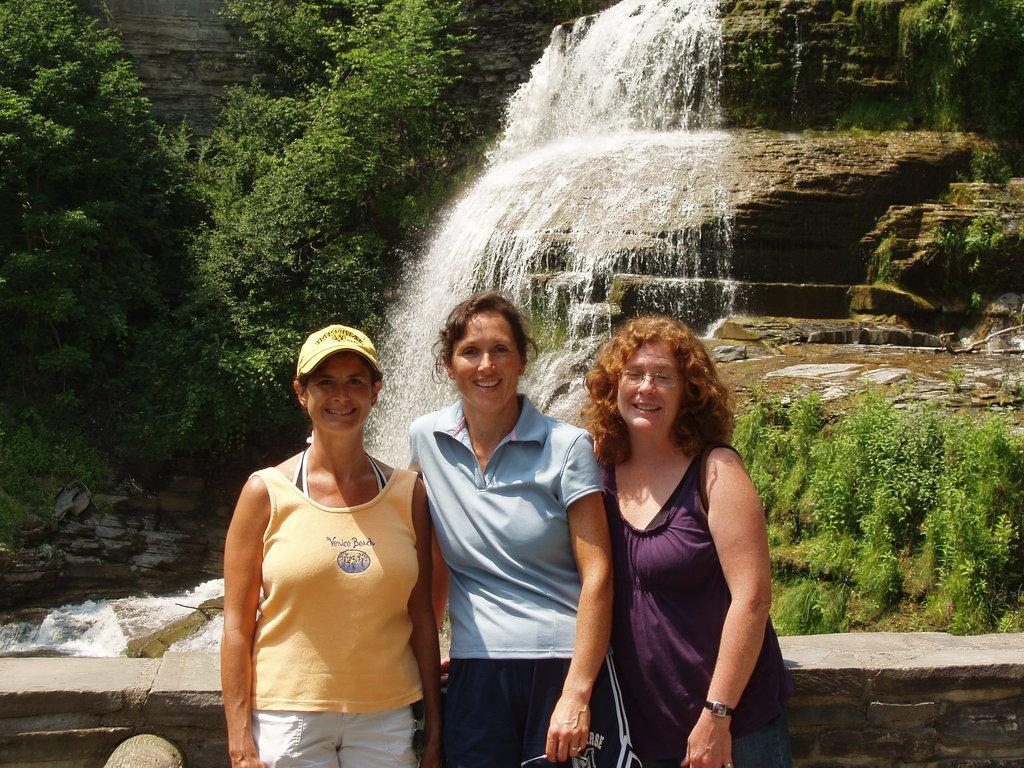How many women are in the image? There are three women in the image. What are the women doing in the image? The women are standing and smiling. What can be seen on the left and right sides of the image? There is a wall visible from left to right in the image. What is visible in the background of the image? There is a waterfall and trees in the background of the image. What shape is the bun that the women are wearing in the image? There are no buns visible on the women's heads in the image. Can you see a mountain in the background of the image? There is no mountain present in the image; it features a waterfall and trees in the background. 